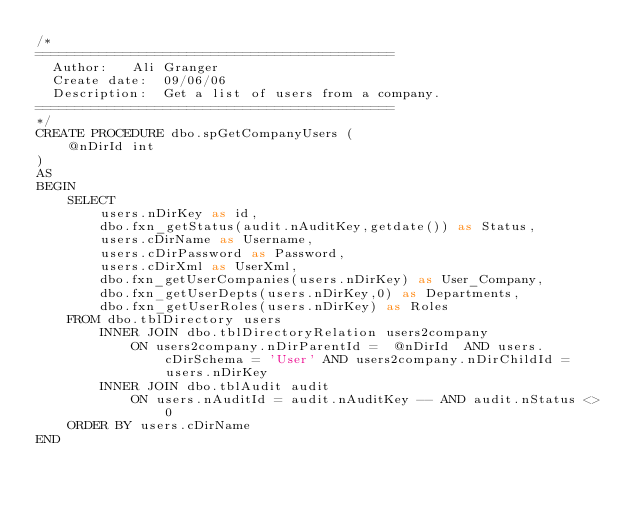Convert code to text. <code><loc_0><loc_0><loc_500><loc_500><_SQL_>/* 
=============================================
  Author:	Ali Granger
  Create date: 	09/06/06
  Description:	Get a list of users from a company.
=============================================
*/
CREATE PROCEDURE dbo.spGetCompanyUsers (
	@nDirId int
)
AS
BEGIN
	SELECT
		users.nDirKey as id, 
		dbo.fxn_getStatus(audit.nAuditKey,getdate()) as Status,  
		users.cDirName as Username, 
		users.cDirPassword as Password, 
		users.cDirXml as UserXml,
		dbo.fxn_getUserCompanies(users.nDirKey) as User_Company, 
		dbo.fxn_getUserDepts(users.nDirKey,0) as Departments, 
		dbo.fxn_getUserRoles(users.nDirKey) as Roles 
	FROM dbo.tblDirectory users
		INNER JOIN dbo.tblDirectoryRelation users2company
			ON users2company.nDirParentId =  @nDirId  AND users.cDirSchema = 'User' AND users2company.nDirChildId = users.nDirKey
		INNER JOIN dbo.tblAudit audit
			ON users.nAuditId = audit.nAuditKey -- AND audit.nStatus <> 0
	ORDER BY users.cDirName 
END</code> 